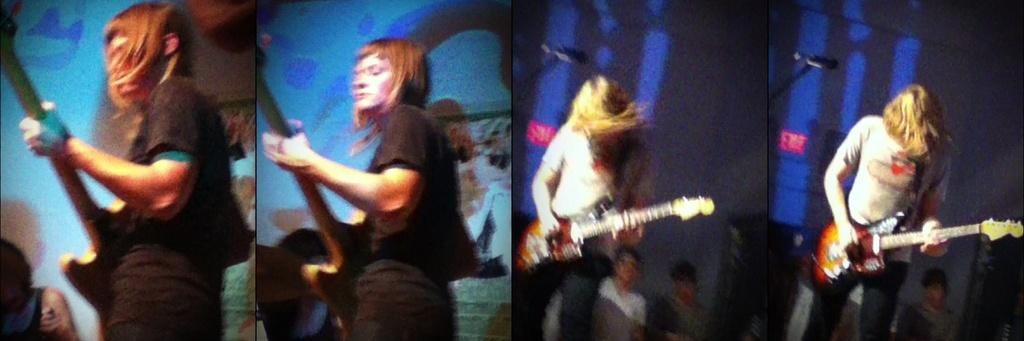How many images are included in the collage? The image is a collage edit with 4 images. What can be seen in each of the images? There are 4 women in the pictures, and all of them are playing guitar. What type of note is being passed between the women in the image? There is no note being passed between the women in the image; they are all playing guitar. What role does the air play in the image? The air does not play a role in the image; it is a static representation of the women playing guitar. 